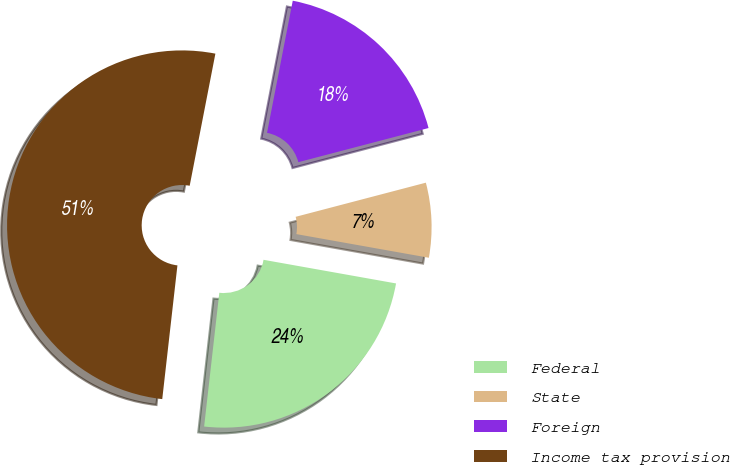Convert chart to OTSL. <chart><loc_0><loc_0><loc_500><loc_500><pie_chart><fcel>Federal<fcel>State<fcel>Foreign<fcel>Income tax provision<nl><fcel>23.99%<fcel>6.89%<fcel>17.86%<fcel>51.26%<nl></chart> 